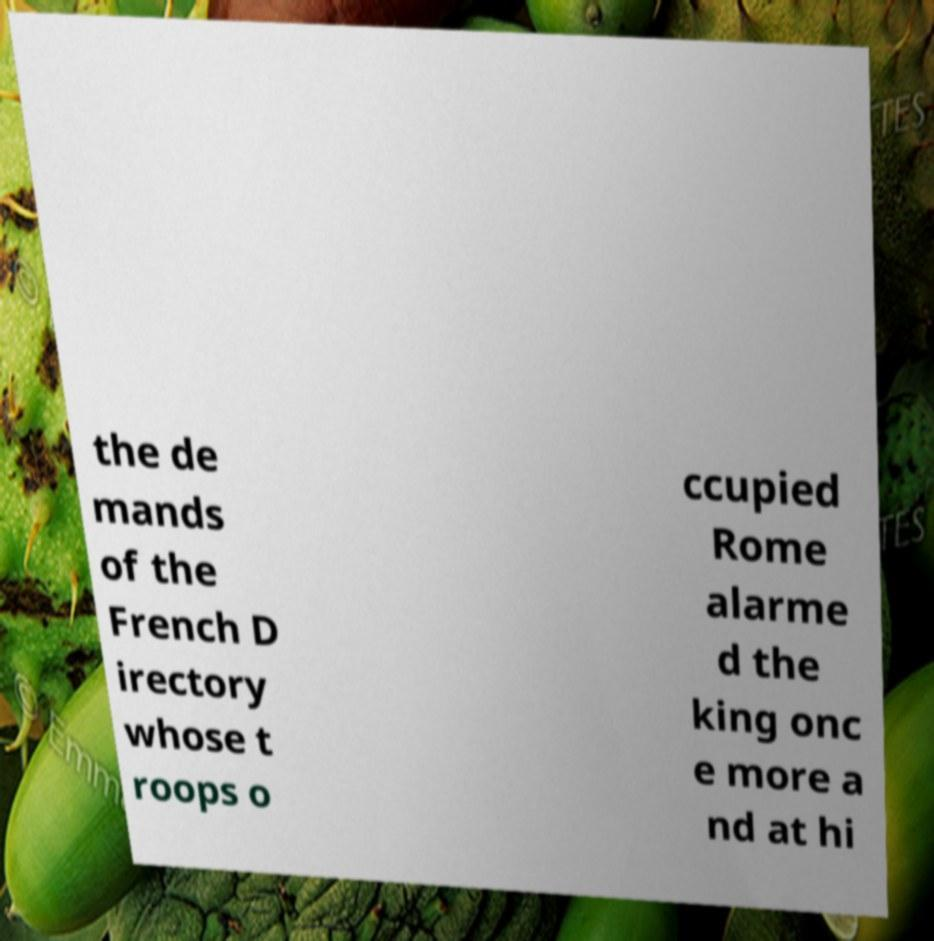For documentation purposes, I need the text within this image transcribed. Could you provide that? the de mands of the French D irectory whose t roops o ccupied Rome alarme d the king onc e more a nd at hi 